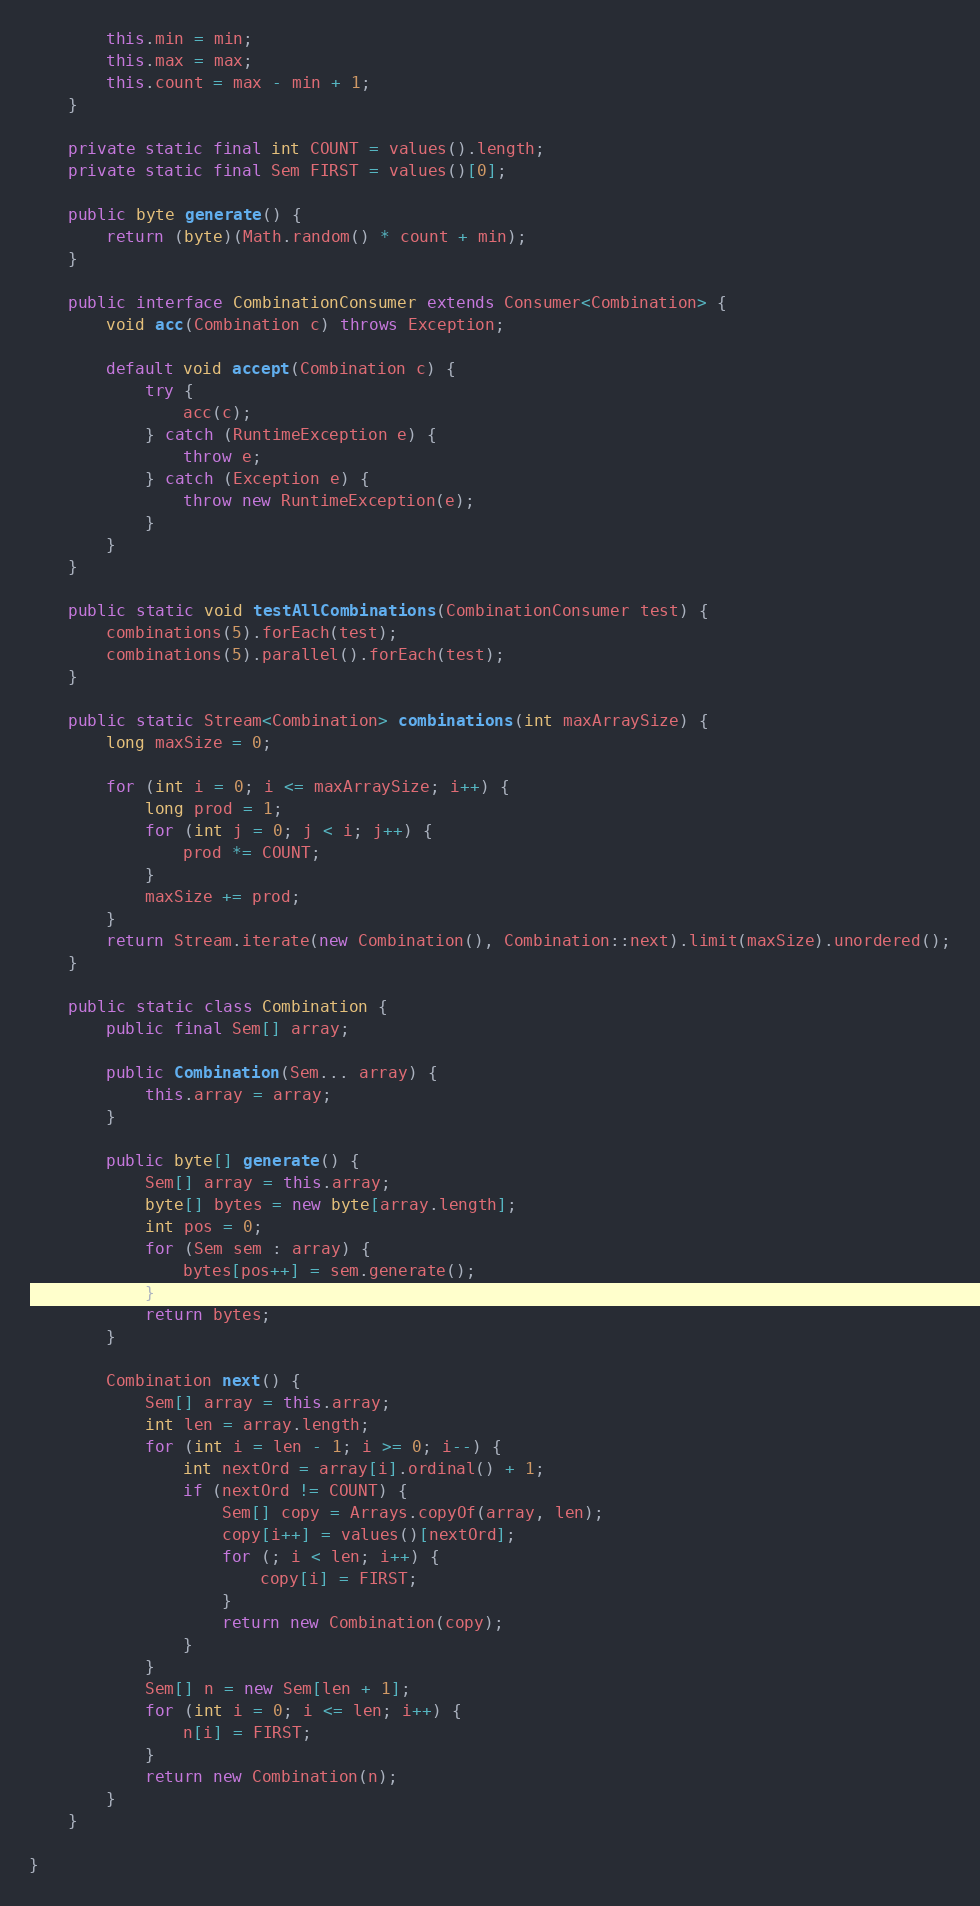<code> <loc_0><loc_0><loc_500><loc_500><_Java_>        this.min = min;
        this.max = max;
        this.count = max - min + 1;
    }

    private static final int COUNT = values().length;
    private static final Sem FIRST = values()[0];

    public byte generate() {
        return (byte)(Math.random() * count + min);
    }

    public interface CombinationConsumer extends Consumer<Combination> {
        void acc(Combination c) throws Exception;

        default void accept(Combination c) {
            try {
                acc(c);
            } catch (RuntimeException e) {
                throw e;
            } catch (Exception e) {
                throw new RuntimeException(e);
            }
        }
    }

    public static void testAllCombinations(CombinationConsumer test) {
        combinations(5).forEach(test);
        combinations(5).parallel().forEach(test);
    }

    public static Stream<Combination> combinations(int maxArraySize) {
        long maxSize = 0;

        for (int i = 0; i <= maxArraySize; i++) {
            long prod = 1;
            for (int j = 0; j < i; j++) {
                prod *= COUNT;
            }
            maxSize += prod;
        }
        return Stream.iterate(new Combination(), Combination::next).limit(maxSize).unordered();
    }

    public static class Combination {
        public final Sem[] array;

        public Combination(Sem... array) {
            this.array = array;
        }

        public byte[] generate() {
            Sem[] array = this.array;
            byte[] bytes = new byte[array.length];
            int pos = 0;
            for (Sem sem : array) {
                bytes[pos++] = sem.generate();
            }
            return bytes;
        }

        Combination next() {
            Sem[] array = this.array;
            int len = array.length;
            for (int i = len - 1; i >= 0; i--) {
                int nextOrd = array[i].ordinal() + 1;
                if (nextOrd != COUNT) {
                    Sem[] copy = Arrays.copyOf(array, len);
                    copy[i++] = values()[nextOrd];
                    for (; i < len; i++) {
                        copy[i] = FIRST;
                    }
                    return new Combination(copy);
                }
            }
            Sem[] n = new Sem[len + 1];
            for (int i = 0; i <= len; i++) {
                n[i] = FIRST;
            }
            return new Combination(n);
        }
    }

}
</code> 